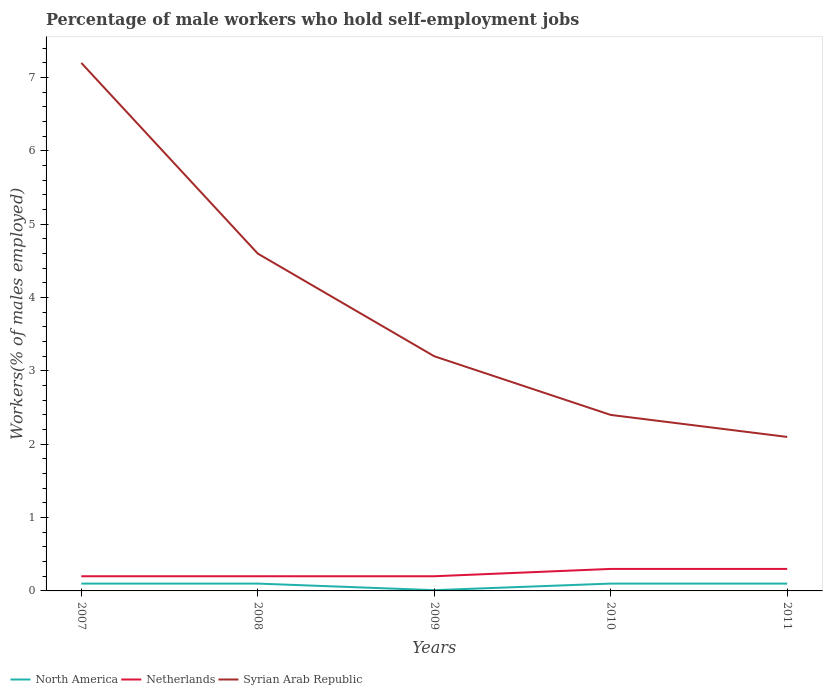Is the number of lines equal to the number of legend labels?
Make the answer very short. Yes. Across all years, what is the maximum percentage of self-employed male workers in Syrian Arab Republic?
Provide a succinct answer. 2.1. What is the total percentage of self-employed male workers in Netherlands in the graph?
Provide a short and direct response. -0.1. What is the difference between the highest and the second highest percentage of self-employed male workers in Syrian Arab Republic?
Ensure brevity in your answer.  5.1. What is the difference between the highest and the lowest percentage of self-employed male workers in Syrian Arab Republic?
Your response must be concise. 2. Is the percentage of self-employed male workers in Netherlands strictly greater than the percentage of self-employed male workers in Syrian Arab Republic over the years?
Your answer should be compact. Yes. Are the values on the major ticks of Y-axis written in scientific E-notation?
Offer a very short reply. No. Does the graph contain any zero values?
Your answer should be very brief. No. Where does the legend appear in the graph?
Your answer should be compact. Bottom left. How are the legend labels stacked?
Your answer should be compact. Horizontal. What is the title of the graph?
Your response must be concise. Percentage of male workers who hold self-employment jobs. Does "Honduras" appear as one of the legend labels in the graph?
Give a very brief answer. No. What is the label or title of the Y-axis?
Your response must be concise. Workers(% of males employed). What is the Workers(% of males employed) in North America in 2007?
Make the answer very short. 0.1. What is the Workers(% of males employed) of Netherlands in 2007?
Keep it short and to the point. 0.2. What is the Workers(% of males employed) in Syrian Arab Republic in 2007?
Offer a terse response. 7.2. What is the Workers(% of males employed) in North America in 2008?
Your answer should be very brief. 0.1. What is the Workers(% of males employed) in Netherlands in 2008?
Provide a short and direct response. 0.2. What is the Workers(% of males employed) of Syrian Arab Republic in 2008?
Keep it short and to the point. 4.6. What is the Workers(% of males employed) in North America in 2009?
Your answer should be very brief. 0.01. What is the Workers(% of males employed) of Netherlands in 2009?
Make the answer very short. 0.2. What is the Workers(% of males employed) of Syrian Arab Republic in 2009?
Keep it short and to the point. 3.2. What is the Workers(% of males employed) in North America in 2010?
Offer a very short reply. 0.1. What is the Workers(% of males employed) of Netherlands in 2010?
Make the answer very short. 0.3. What is the Workers(% of males employed) of Syrian Arab Republic in 2010?
Offer a terse response. 2.4. What is the Workers(% of males employed) in North America in 2011?
Your answer should be compact. 0.1. What is the Workers(% of males employed) of Netherlands in 2011?
Give a very brief answer. 0.3. What is the Workers(% of males employed) in Syrian Arab Republic in 2011?
Give a very brief answer. 2.1. Across all years, what is the maximum Workers(% of males employed) of North America?
Give a very brief answer. 0.1. Across all years, what is the maximum Workers(% of males employed) in Netherlands?
Offer a terse response. 0.3. Across all years, what is the maximum Workers(% of males employed) in Syrian Arab Republic?
Ensure brevity in your answer.  7.2. Across all years, what is the minimum Workers(% of males employed) in North America?
Keep it short and to the point. 0.01. Across all years, what is the minimum Workers(% of males employed) in Netherlands?
Your response must be concise. 0.2. Across all years, what is the minimum Workers(% of males employed) of Syrian Arab Republic?
Offer a very short reply. 2.1. What is the total Workers(% of males employed) in North America in the graph?
Your response must be concise. 0.41. What is the total Workers(% of males employed) of Netherlands in the graph?
Make the answer very short. 1.2. What is the total Workers(% of males employed) in Syrian Arab Republic in the graph?
Keep it short and to the point. 19.5. What is the difference between the Workers(% of males employed) in North America in 2007 and that in 2008?
Offer a very short reply. 0. What is the difference between the Workers(% of males employed) of Syrian Arab Republic in 2007 and that in 2008?
Your response must be concise. 2.6. What is the difference between the Workers(% of males employed) in North America in 2007 and that in 2009?
Your response must be concise. 0.09. What is the difference between the Workers(% of males employed) of Netherlands in 2007 and that in 2009?
Provide a short and direct response. 0. What is the difference between the Workers(% of males employed) of Syrian Arab Republic in 2007 and that in 2009?
Give a very brief answer. 4. What is the difference between the Workers(% of males employed) in North America in 2007 and that in 2010?
Your answer should be very brief. 0. What is the difference between the Workers(% of males employed) of Netherlands in 2007 and that in 2010?
Your answer should be compact. -0.1. What is the difference between the Workers(% of males employed) in Syrian Arab Republic in 2007 and that in 2010?
Offer a terse response. 4.8. What is the difference between the Workers(% of males employed) in North America in 2007 and that in 2011?
Offer a very short reply. 0. What is the difference between the Workers(% of males employed) in Netherlands in 2007 and that in 2011?
Your answer should be compact. -0.1. What is the difference between the Workers(% of males employed) in Syrian Arab Republic in 2007 and that in 2011?
Provide a short and direct response. 5.1. What is the difference between the Workers(% of males employed) in North America in 2008 and that in 2009?
Your answer should be compact. 0.09. What is the difference between the Workers(% of males employed) in Netherlands in 2008 and that in 2009?
Provide a short and direct response. 0. What is the difference between the Workers(% of males employed) of North America in 2008 and that in 2010?
Your answer should be compact. 0. What is the difference between the Workers(% of males employed) of Syrian Arab Republic in 2008 and that in 2010?
Your answer should be very brief. 2.2. What is the difference between the Workers(% of males employed) of North America in 2008 and that in 2011?
Give a very brief answer. 0. What is the difference between the Workers(% of males employed) of Syrian Arab Republic in 2008 and that in 2011?
Provide a short and direct response. 2.5. What is the difference between the Workers(% of males employed) in North America in 2009 and that in 2010?
Give a very brief answer. -0.09. What is the difference between the Workers(% of males employed) in Syrian Arab Republic in 2009 and that in 2010?
Your answer should be very brief. 0.8. What is the difference between the Workers(% of males employed) of North America in 2009 and that in 2011?
Ensure brevity in your answer.  -0.09. What is the difference between the Workers(% of males employed) in Netherlands in 2009 and that in 2011?
Your response must be concise. -0.1. What is the difference between the Workers(% of males employed) in Syrian Arab Republic in 2009 and that in 2011?
Provide a short and direct response. 1.1. What is the difference between the Workers(% of males employed) of North America in 2010 and that in 2011?
Your answer should be compact. 0. What is the difference between the Workers(% of males employed) in Netherlands in 2007 and the Workers(% of males employed) in Syrian Arab Republic in 2008?
Offer a very short reply. -4.4. What is the difference between the Workers(% of males employed) of North America in 2007 and the Workers(% of males employed) of Netherlands in 2009?
Keep it short and to the point. -0.1. What is the difference between the Workers(% of males employed) in North America in 2007 and the Workers(% of males employed) in Syrian Arab Republic in 2009?
Offer a very short reply. -3.1. What is the difference between the Workers(% of males employed) in North America in 2007 and the Workers(% of males employed) in Netherlands in 2010?
Your answer should be compact. -0.2. What is the difference between the Workers(% of males employed) of North America in 2007 and the Workers(% of males employed) of Syrian Arab Republic in 2010?
Offer a very short reply. -2.3. What is the difference between the Workers(% of males employed) of North America in 2007 and the Workers(% of males employed) of Netherlands in 2011?
Provide a short and direct response. -0.2. What is the difference between the Workers(% of males employed) of North America in 2007 and the Workers(% of males employed) of Syrian Arab Republic in 2011?
Offer a terse response. -2. What is the difference between the Workers(% of males employed) in North America in 2008 and the Workers(% of males employed) in Netherlands in 2010?
Your answer should be very brief. -0.2. What is the difference between the Workers(% of males employed) in Netherlands in 2008 and the Workers(% of males employed) in Syrian Arab Republic in 2010?
Make the answer very short. -2.2. What is the difference between the Workers(% of males employed) in North America in 2008 and the Workers(% of males employed) in Netherlands in 2011?
Give a very brief answer. -0.2. What is the difference between the Workers(% of males employed) of North America in 2008 and the Workers(% of males employed) of Syrian Arab Republic in 2011?
Make the answer very short. -2. What is the difference between the Workers(% of males employed) in North America in 2009 and the Workers(% of males employed) in Netherlands in 2010?
Give a very brief answer. -0.29. What is the difference between the Workers(% of males employed) in North America in 2009 and the Workers(% of males employed) in Syrian Arab Republic in 2010?
Your answer should be compact. -2.39. What is the difference between the Workers(% of males employed) of Netherlands in 2009 and the Workers(% of males employed) of Syrian Arab Republic in 2010?
Your response must be concise. -2.2. What is the difference between the Workers(% of males employed) of North America in 2009 and the Workers(% of males employed) of Netherlands in 2011?
Give a very brief answer. -0.29. What is the difference between the Workers(% of males employed) in North America in 2009 and the Workers(% of males employed) in Syrian Arab Republic in 2011?
Your answer should be compact. -2.09. What is the difference between the Workers(% of males employed) of North America in 2010 and the Workers(% of males employed) of Netherlands in 2011?
Ensure brevity in your answer.  -0.2. What is the difference between the Workers(% of males employed) in North America in 2010 and the Workers(% of males employed) in Syrian Arab Republic in 2011?
Your response must be concise. -2. What is the difference between the Workers(% of males employed) in Netherlands in 2010 and the Workers(% of males employed) in Syrian Arab Republic in 2011?
Keep it short and to the point. -1.8. What is the average Workers(% of males employed) in North America per year?
Give a very brief answer. 0.08. What is the average Workers(% of males employed) of Netherlands per year?
Offer a terse response. 0.24. What is the average Workers(% of males employed) in Syrian Arab Republic per year?
Your answer should be compact. 3.9. In the year 2007, what is the difference between the Workers(% of males employed) in North America and Workers(% of males employed) in Netherlands?
Ensure brevity in your answer.  -0.1. In the year 2007, what is the difference between the Workers(% of males employed) of North America and Workers(% of males employed) of Syrian Arab Republic?
Make the answer very short. -7.1. In the year 2007, what is the difference between the Workers(% of males employed) in Netherlands and Workers(% of males employed) in Syrian Arab Republic?
Keep it short and to the point. -7. In the year 2008, what is the difference between the Workers(% of males employed) of North America and Workers(% of males employed) of Netherlands?
Keep it short and to the point. -0.1. In the year 2008, what is the difference between the Workers(% of males employed) in North America and Workers(% of males employed) in Syrian Arab Republic?
Provide a short and direct response. -4.5. In the year 2008, what is the difference between the Workers(% of males employed) in Netherlands and Workers(% of males employed) in Syrian Arab Republic?
Provide a short and direct response. -4.4. In the year 2009, what is the difference between the Workers(% of males employed) of North America and Workers(% of males employed) of Netherlands?
Provide a short and direct response. -0.19. In the year 2009, what is the difference between the Workers(% of males employed) of North America and Workers(% of males employed) of Syrian Arab Republic?
Your answer should be compact. -3.19. In the year 2010, what is the difference between the Workers(% of males employed) in North America and Workers(% of males employed) in Netherlands?
Provide a short and direct response. -0.2. In the year 2011, what is the difference between the Workers(% of males employed) of Netherlands and Workers(% of males employed) of Syrian Arab Republic?
Offer a very short reply. -1.8. What is the ratio of the Workers(% of males employed) of North America in 2007 to that in 2008?
Your response must be concise. 1. What is the ratio of the Workers(% of males employed) of Netherlands in 2007 to that in 2008?
Ensure brevity in your answer.  1. What is the ratio of the Workers(% of males employed) of Syrian Arab Republic in 2007 to that in 2008?
Keep it short and to the point. 1.57. What is the ratio of the Workers(% of males employed) in North America in 2007 to that in 2009?
Your response must be concise. 9.5. What is the ratio of the Workers(% of males employed) of Netherlands in 2007 to that in 2009?
Offer a terse response. 1. What is the ratio of the Workers(% of males employed) of Syrian Arab Republic in 2007 to that in 2009?
Make the answer very short. 2.25. What is the ratio of the Workers(% of males employed) of Netherlands in 2007 to that in 2011?
Give a very brief answer. 0.67. What is the ratio of the Workers(% of males employed) of Syrian Arab Republic in 2007 to that in 2011?
Provide a succinct answer. 3.43. What is the ratio of the Workers(% of males employed) in North America in 2008 to that in 2009?
Keep it short and to the point. 9.5. What is the ratio of the Workers(% of males employed) in Netherlands in 2008 to that in 2009?
Give a very brief answer. 1. What is the ratio of the Workers(% of males employed) of Syrian Arab Republic in 2008 to that in 2009?
Your response must be concise. 1.44. What is the ratio of the Workers(% of males employed) of North America in 2008 to that in 2010?
Ensure brevity in your answer.  1. What is the ratio of the Workers(% of males employed) of Syrian Arab Republic in 2008 to that in 2010?
Keep it short and to the point. 1.92. What is the ratio of the Workers(% of males employed) of North America in 2008 to that in 2011?
Make the answer very short. 1. What is the ratio of the Workers(% of males employed) of Netherlands in 2008 to that in 2011?
Offer a terse response. 0.67. What is the ratio of the Workers(% of males employed) of Syrian Arab Republic in 2008 to that in 2011?
Your answer should be very brief. 2.19. What is the ratio of the Workers(% of males employed) in North America in 2009 to that in 2010?
Offer a terse response. 0.11. What is the ratio of the Workers(% of males employed) in North America in 2009 to that in 2011?
Keep it short and to the point. 0.11. What is the ratio of the Workers(% of males employed) in Netherlands in 2009 to that in 2011?
Your answer should be compact. 0.67. What is the ratio of the Workers(% of males employed) of Syrian Arab Republic in 2009 to that in 2011?
Make the answer very short. 1.52. What is the ratio of the Workers(% of males employed) of Netherlands in 2010 to that in 2011?
Offer a very short reply. 1. What is the difference between the highest and the second highest Workers(% of males employed) in Syrian Arab Republic?
Provide a short and direct response. 2.6. What is the difference between the highest and the lowest Workers(% of males employed) of North America?
Provide a short and direct response. 0.09. What is the difference between the highest and the lowest Workers(% of males employed) in Netherlands?
Keep it short and to the point. 0.1. What is the difference between the highest and the lowest Workers(% of males employed) of Syrian Arab Republic?
Offer a very short reply. 5.1. 